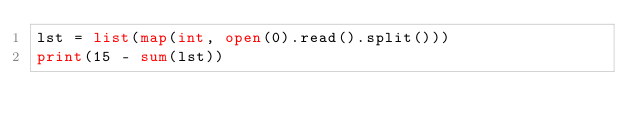<code> <loc_0><loc_0><loc_500><loc_500><_Python_>lst = list(map(int, open(0).read().split()))
print(15 - sum(lst))
</code> 